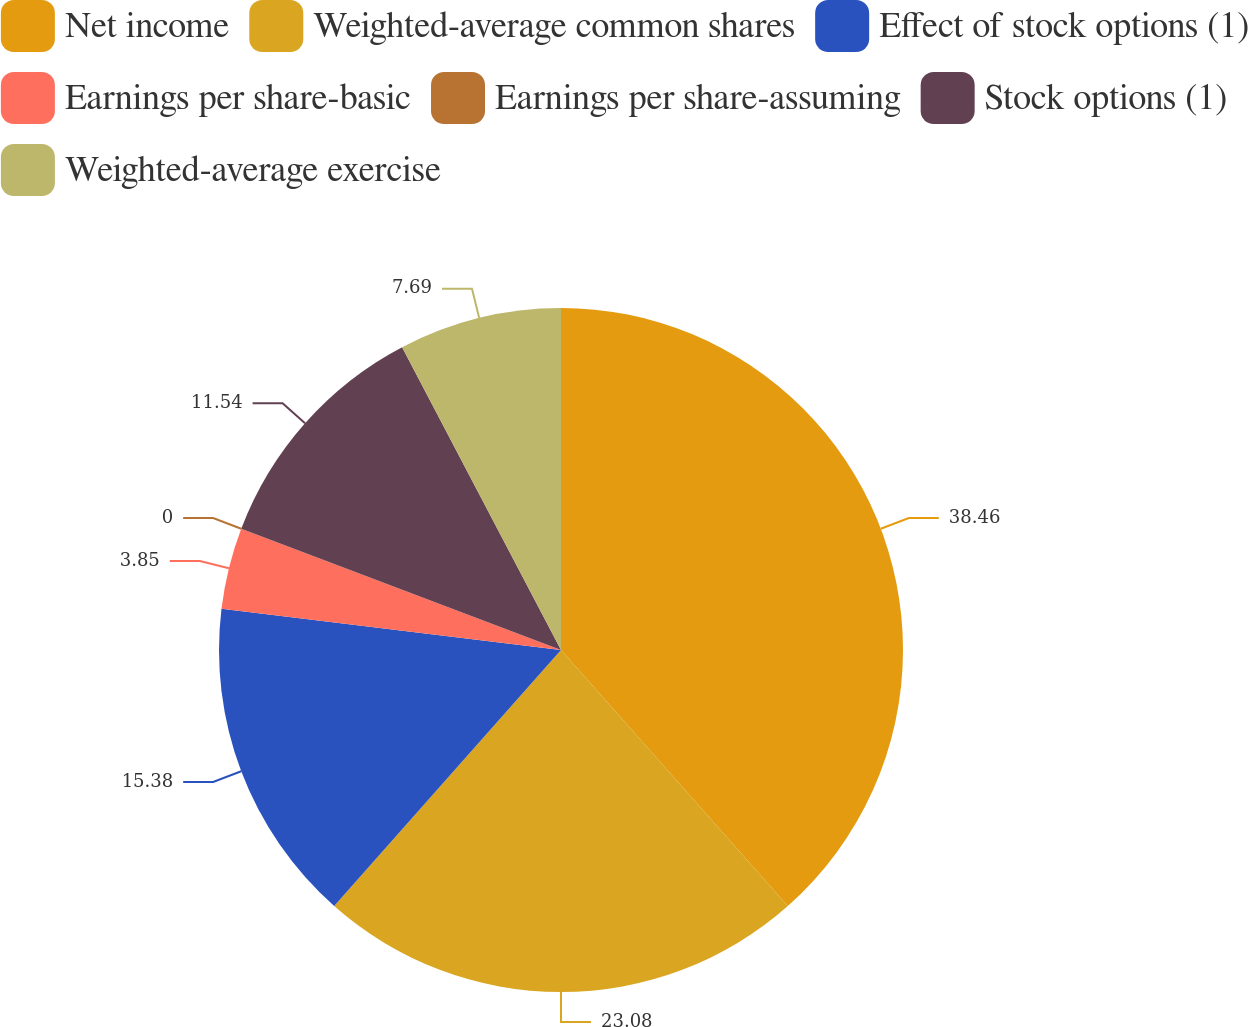Convert chart to OTSL. <chart><loc_0><loc_0><loc_500><loc_500><pie_chart><fcel>Net income<fcel>Weighted-average common shares<fcel>Effect of stock options (1)<fcel>Earnings per share-basic<fcel>Earnings per share-assuming<fcel>Stock options (1)<fcel>Weighted-average exercise<nl><fcel>38.46%<fcel>23.08%<fcel>15.38%<fcel>3.85%<fcel>0.0%<fcel>11.54%<fcel>7.69%<nl></chart> 